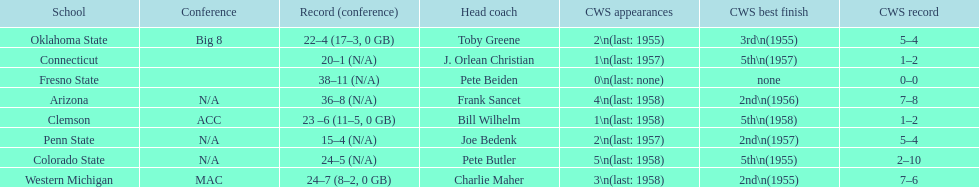List the schools that came in last place in the cws best finish. Clemson, Colorado State, Connecticut. I'm looking to parse the entire table for insights. Could you assist me with that? {'header': ['School', 'Conference', 'Record (conference)', 'Head coach', 'CWS appearances', 'CWS best finish', 'CWS record'], 'rows': [['Oklahoma State', 'Big 8', '22–4 (17–3, 0 GB)', 'Toby Greene', '2\\n(last: 1955)', '3rd\\n(1955)', '5–4'], ['Connecticut', '', '20–1 (N/A)', 'J. Orlean Christian', '1\\n(last: 1957)', '5th\\n(1957)', '1–2'], ['Fresno State', '', '38–11 (N/A)', 'Pete Beiden', '0\\n(last: none)', 'none', '0–0'], ['Arizona', 'N/A', '36–8 (N/A)', 'Frank Sancet', '4\\n(last: 1958)', '2nd\\n(1956)', '7–8'], ['Clemson', 'ACC', '23 –6 (11–5, 0 GB)', 'Bill Wilhelm', '1\\n(last: 1958)', '5th\\n(1958)', '1–2'], ['Penn State', 'N/A', '15–4 (N/A)', 'Joe Bedenk', '2\\n(last: 1957)', '2nd\\n(1957)', '5–4'], ['Colorado State', 'N/A', '24–5 (N/A)', 'Pete Butler', '5\\n(last: 1958)', '5th\\n(1955)', '2–10'], ['Western Michigan', 'MAC', '24–7 (8–2, 0 GB)', 'Charlie Maher', '3\\n(last: 1958)', '2nd\\n(1955)', '7–6']]} 